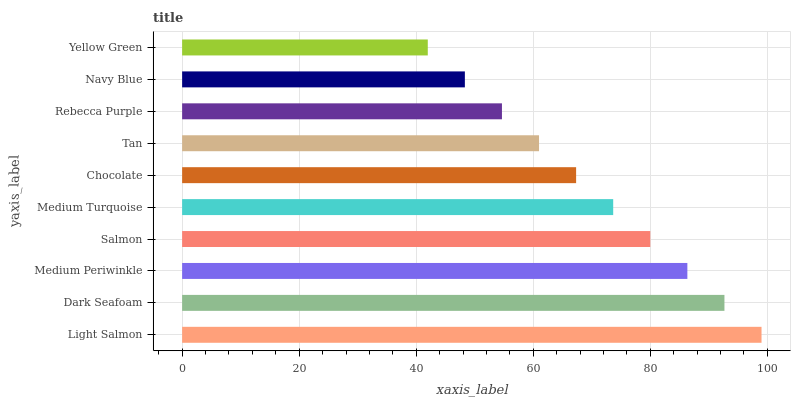Is Yellow Green the minimum?
Answer yes or no. Yes. Is Light Salmon the maximum?
Answer yes or no. Yes. Is Dark Seafoam the minimum?
Answer yes or no. No. Is Dark Seafoam the maximum?
Answer yes or no. No. Is Light Salmon greater than Dark Seafoam?
Answer yes or no. Yes. Is Dark Seafoam less than Light Salmon?
Answer yes or no. Yes. Is Dark Seafoam greater than Light Salmon?
Answer yes or no. No. Is Light Salmon less than Dark Seafoam?
Answer yes or no. No. Is Medium Turquoise the high median?
Answer yes or no. Yes. Is Chocolate the low median?
Answer yes or no. Yes. Is Yellow Green the high median?
Answer yes or no. No. Is Medium Periwinkle the low median?
Answer yes or no. No. 